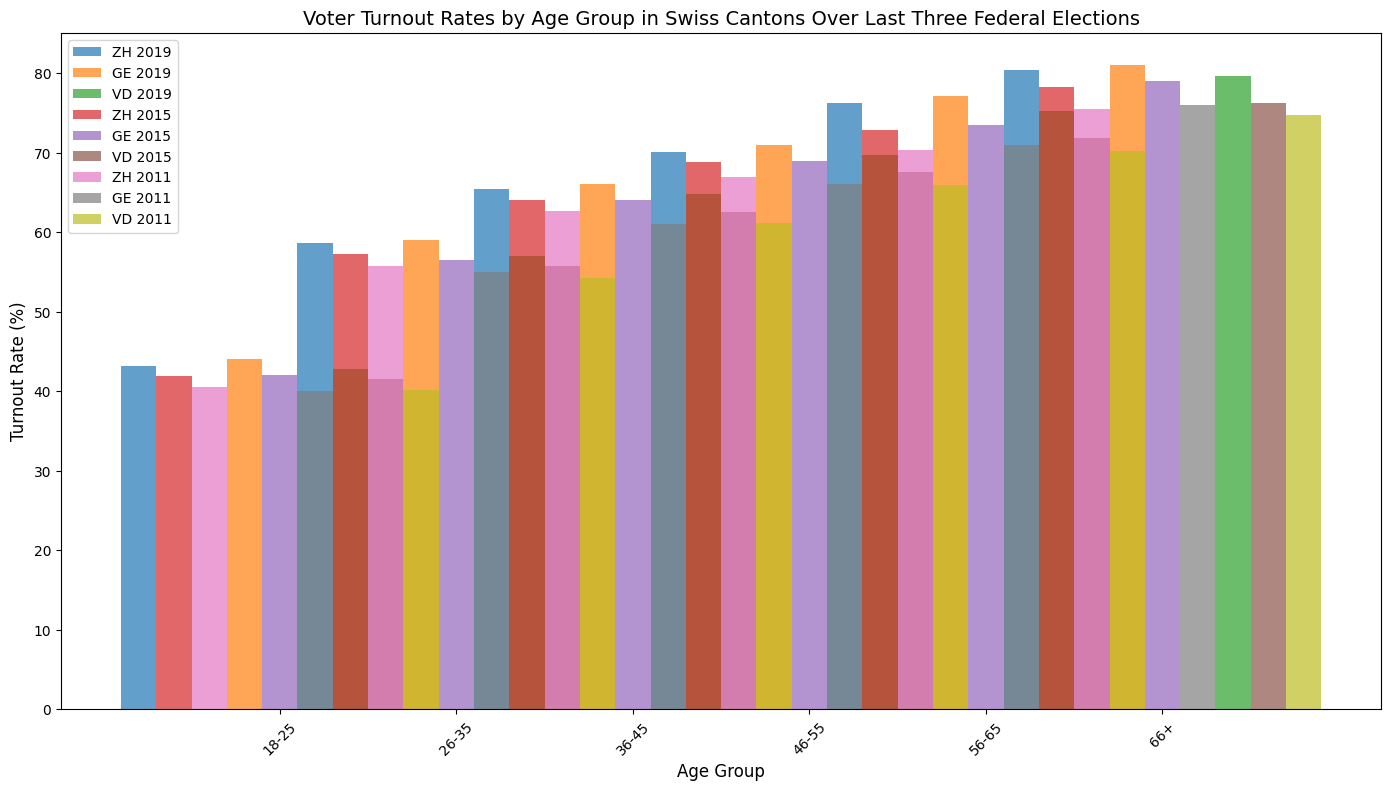What is the overall trend in voter turnout rates across all age groups in Zurich (ZH) from 2011 to 2019? To find the overall trend, observe the heights of the bars for Zurich (ZH) across the years 2011, 2015, and 2019. Notice that for all age groups, the voter turnout rates have increased from 2011 to 2019.
Answer: Increasing Which age group in Geneva (GE) had the highest turnout rate in 2019? Look for the tallest bar in the Geneva 2019 segment. The highest voter turnout rate in 2019 is for the 66+ age group.
Answer: 66+ How does the voter turnout rate for the 18-25 age group in Vaud (VD) compare to that in Zurich (ZH) in 2019? Locate the bars for the 18-25 age group in Vaud and Zurich for the year 2019. The bar corresponding to Zurich is slightly taller than the one for Vaud, indicating a higher turnout rate in Zurich.
Answer: Higher in Zurich What is the average voter turnout rate for the 26-35 age group across all three cantons in 2015? Compute the average by summing the turnout rates for the 26-35 age group in 2015 for Zurich (57.3), Geneva (56.5), and Vaud (55.7) and dividing by 3. (57.3 + 56.5 + 55.7) / 3 = 56.5
Answer: 56.5 Compare the voter turnout rates of the 46-55 age group between Zurich (ZH) and Geneva (GE) in 2011. Which canton had the higher rate? Examine the bars for the 46-55 age group in 2011 for both Zurich and Geneva. The bar for Zurich is slightly taller, indicating a higher turnout rate in Zurich.
Answer: Zurich What is the difference in voter turnout rates between the 18-25 age group and the 66+ age group in Zurich (ZH) for the year 2019? Subtract the turnout rate for the 18-25 age group from that of the 66+ age group in Zurich for 2019. 80.4 - 43.2 = 37.2
Answer: 37.2 Is there a pattern in the voter turnout rates across age groups in Vaud (VD) for the year 2015? Observe the heights of the bars for each age group in Vaud for 2015. The pattern shows that the turnout rate consistently increases with age.
Answer: Increasing with age Which age group showed the smallest increase in voter turnout rate in Geneva (GE) from 2011 to 2019? Calculate the difference in turnout rates for each age group in Geneva between 2011 and 2019, then find the smallest difference. 18-25: 44.0 - 40.0 = 4.0, 26-35: 59.0 - 55.0 = 4.0, 36-45: 66.0 - 61.0 = 5.0, 46-55: 71.0 - 66.0 = 5.0, 56-65: 77.1 - 71.0 = 6.1, 66+: 81.0 - 76.0 = 5.0. The smallest increase is 4.0 for the 18-25 and 26-35 age groups.
Answer: 18-25 and 26-35 